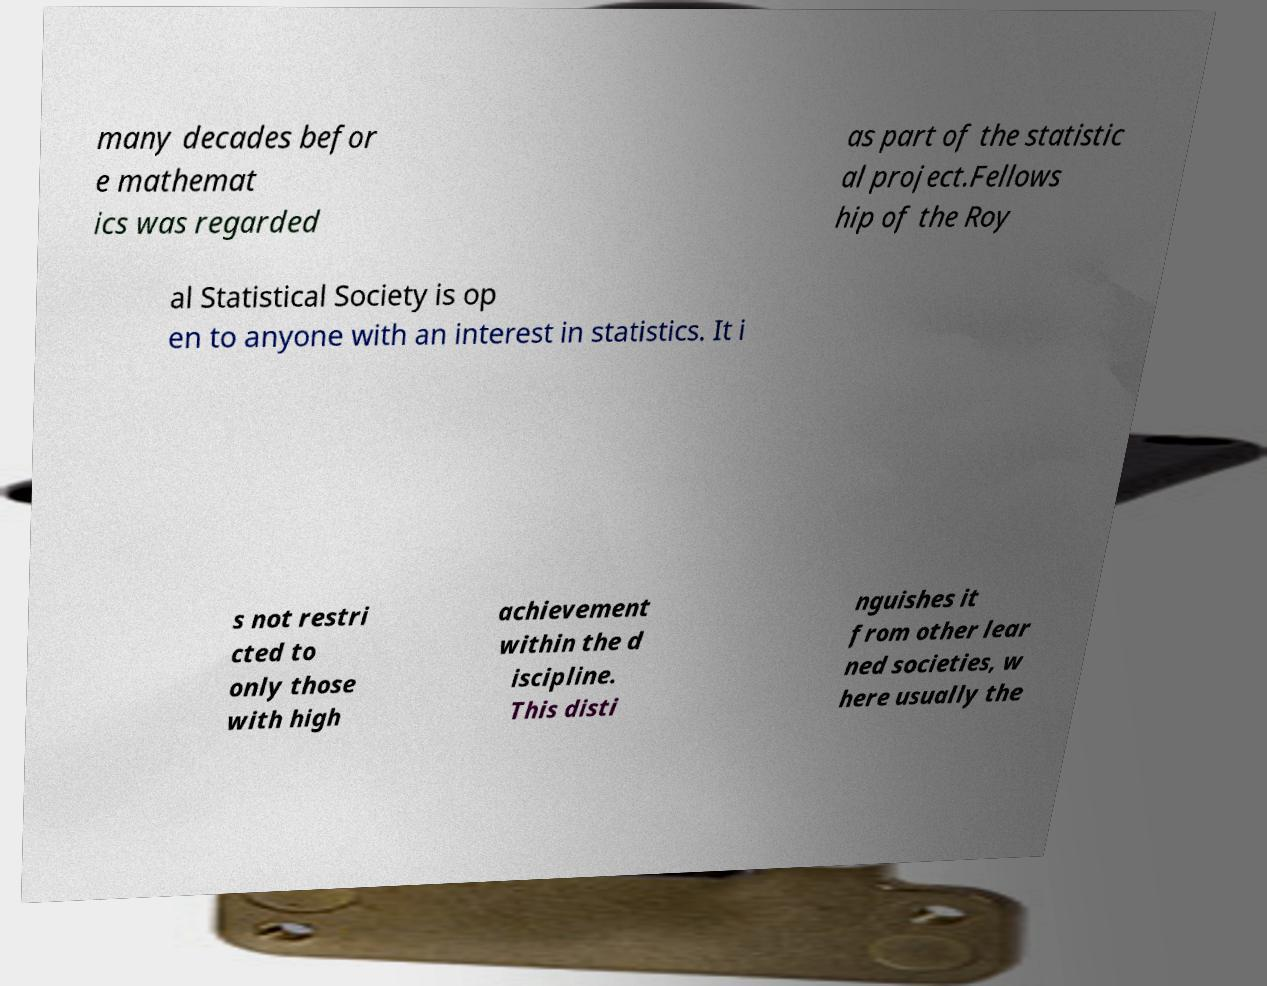There's text embedded in this image that I need extracted. Can you transcribe it verbatim? many decades befor e mathemat ics was regarded as part of the statistic al project.Fellows hip of the Roy al Statistical Society is op en to anyone with an interest in statistics. It i s not restri cted to only those with high achievement within the d iscipline. This disti nguishes it from other lear ned societies, w here usually the 